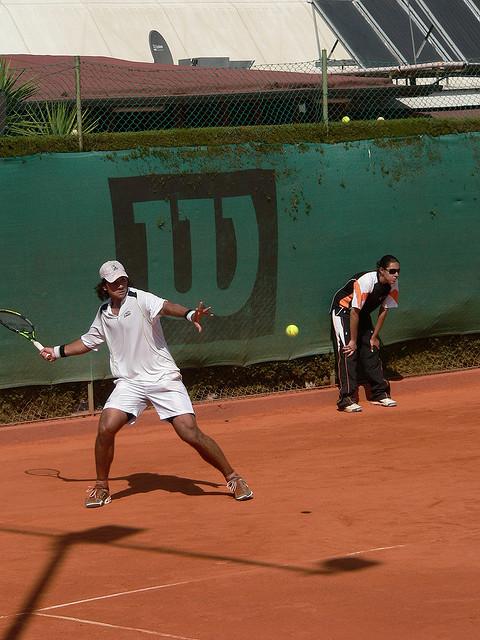What is this sport?
Quick response, please. Tennis. What color is the man on the left's hat?
Quick response, please. White. What letter is on the green screen?
Give a very brief answer. W. What sport is the person playing?
Be succinct. Tennis. 